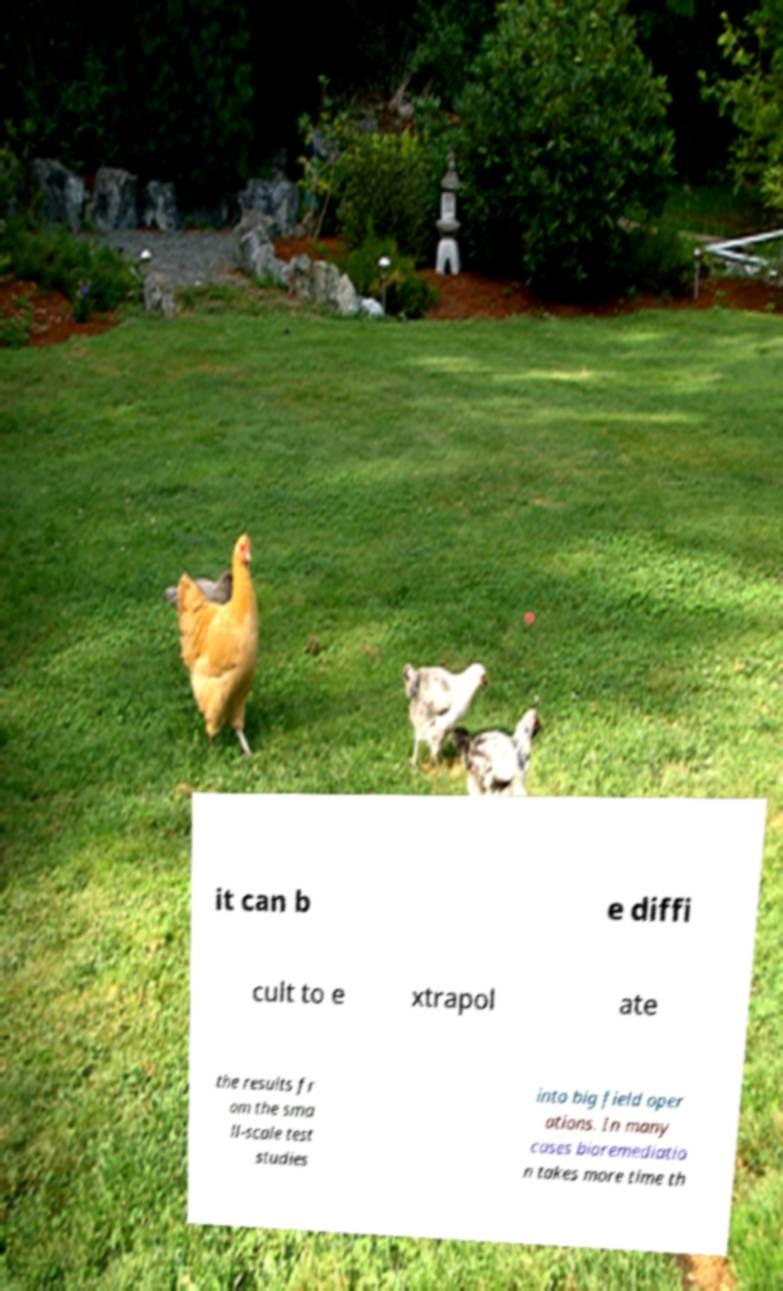What messages or text are displayed in this image? I need them in a readable, typed format. it can b e diffi cult to e xtrapol ate the results fr om the sma ll-scale test studies into big field oper ations. In many cases bioremediatio n takes more time th 